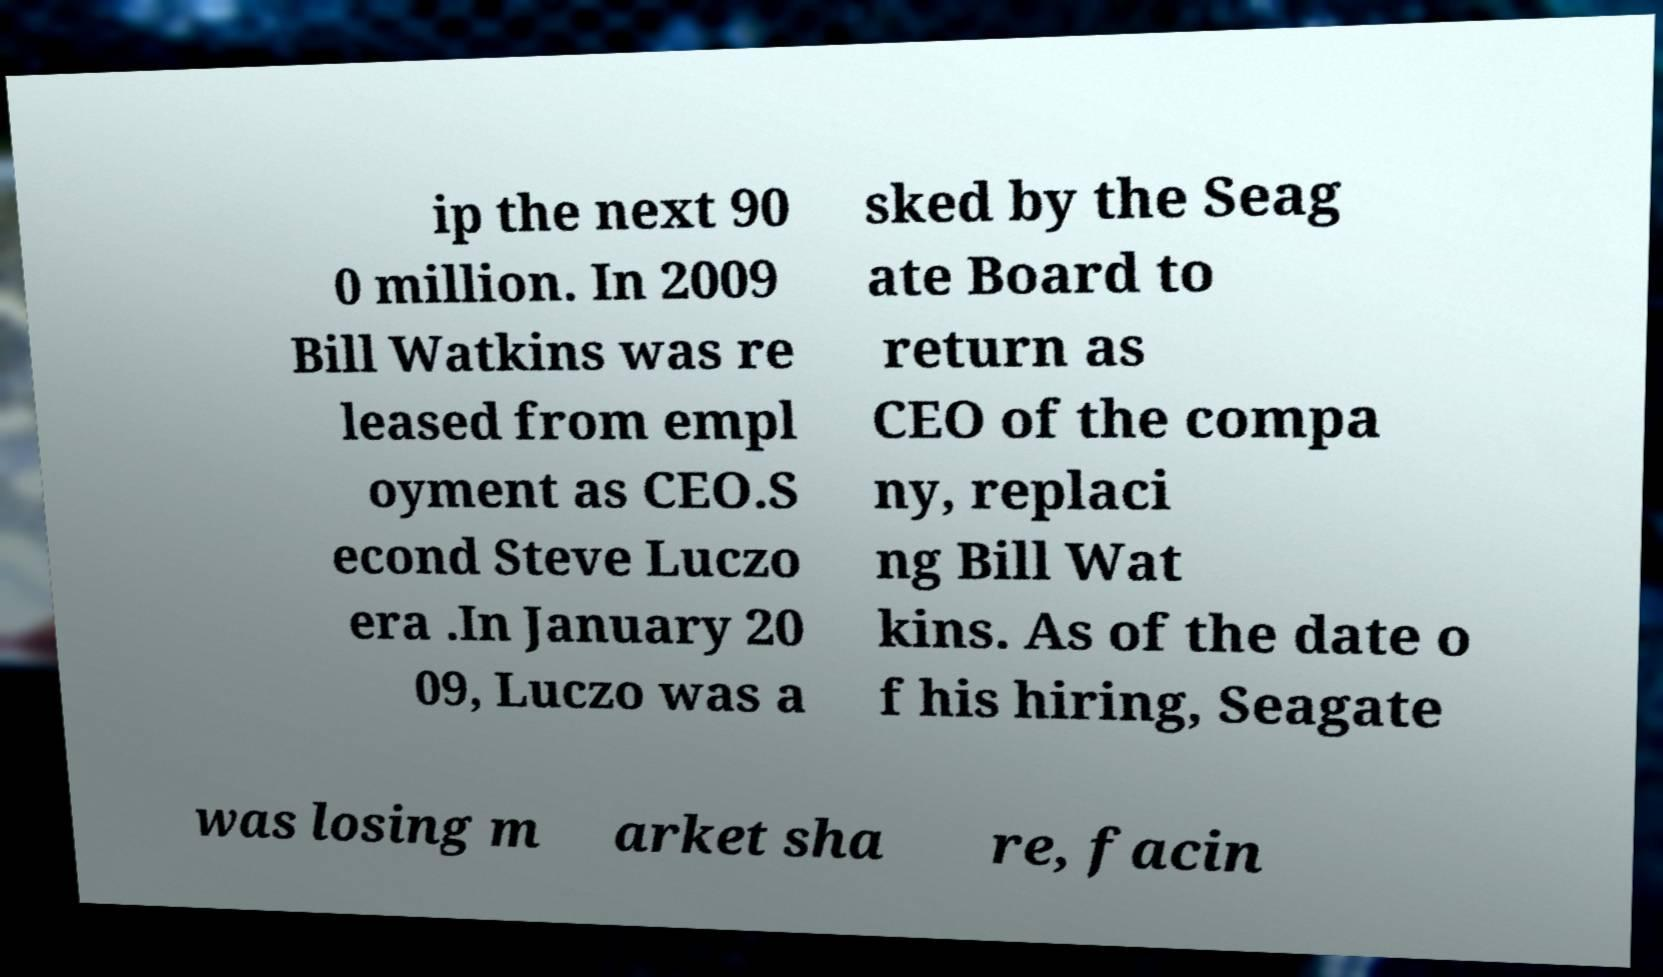Could you extract and type out the text from this image? ip the next 90 0 million. In 2009 Bill Watkins was re leased from empl oyment as CEO.S econd Steve Luczo era .In January 20 09, Luczo was a sked by the Seag ate Board to return as CEO of the compa ny, replaci ng Bill Wat kins. As of the date o f his hiring, Seagate was losing m arket sha re, facin 